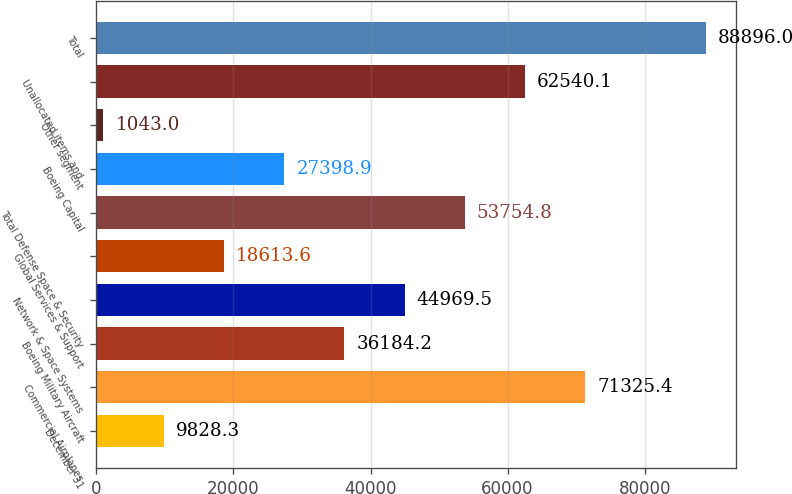<chart> <loc_0><loc_0><loc_500><loc_500><bar_chart><fcel>December 31<fcel>Commercial Airplanes<fcel>Boeing Military Aircraft<fcel>Network & Space Systems<fcel>Global Services & Support<fcel>Total Defense Space & Security<fcel>Boeing Capital<fcel>Other segment<fcel>Unallocated items and<fcel>Total<nl><fcel>9828.3<fcel>71325.4<fcel>36184.2<fcel>44969.5<fcel>18613.6<fcel>53754.8<fcel>27398.9<fcel>1043<fcel>62540.1<fcel>88896<nl></chart> 